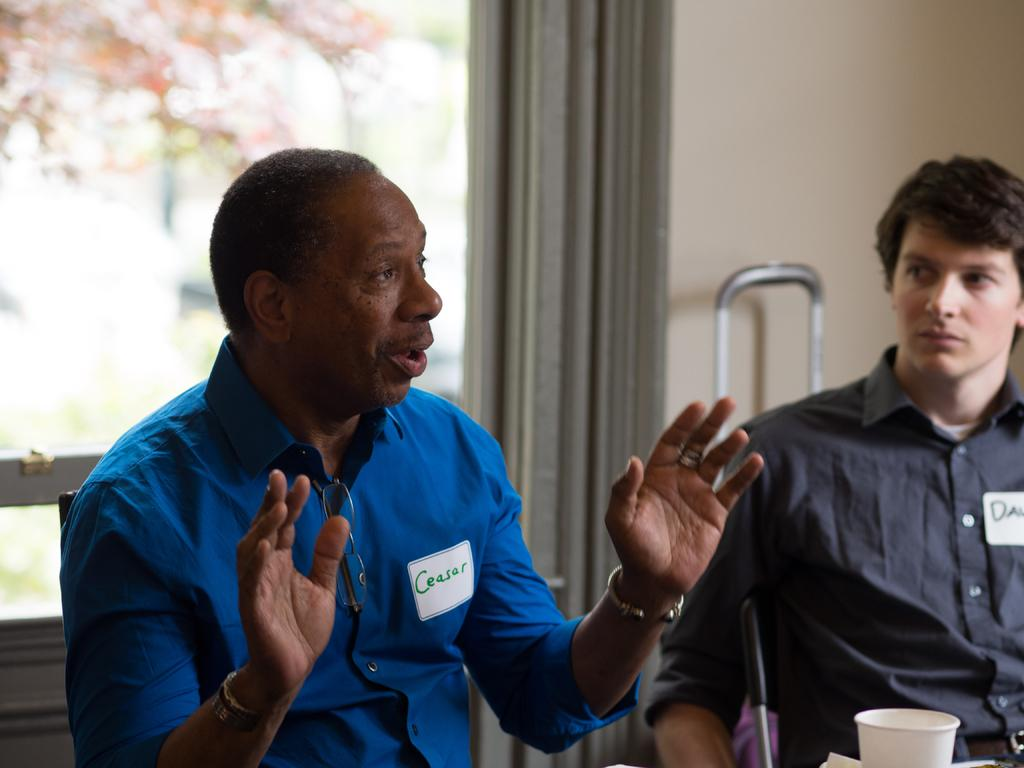What is the man in the image doing? The man is sitting in a chair in the image. Who is with the man in the image? There is another person sitting beside the man in the image. What is the second person doing? The second person is looking at the man. What can be seen in the background of the image? There is a curtain and a wall in the backdrop of the image. What type of branch can be seen hanging from the ceiling in the image? There is no branch hanging from the ceiling in the image; it only features a man, another person, a curtain, and a wall. 